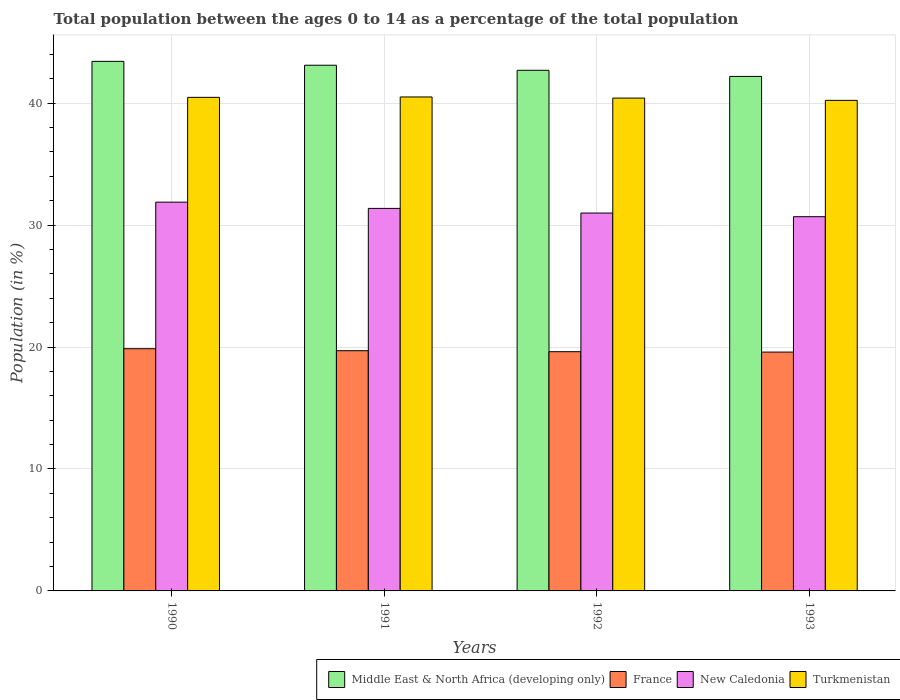How many different coloured bars are there?
Provide a short and direct response. 4. How many groups of bars are there?
Your response must be concise. 4. Are the number of bars on each tick of the X-axis equal?
Ensure brevity in your answer.  Yes. What is the label of the 2nd group of bars from the left?
Offer a very short reply. 1991. In how many cases, is the number of bars for a given year not equal to the number of legend labels?
Provide a short and direct response. 0. What is the percentage of the population ages 0 to 14 in France in 1992?
Give a very brief answer. 19.62. Across all years, what is the maximum percentage of the population ages 0 to 14 in New Caledonia?
Your answer should be compact. 31.88. Across all years, what is the minimum percentage of the population ages 0 to 14 in New Caledonia?
Provide a short and direct response. 30.68. In which year was the percentage of the population ages 0 to 14 in Middle East & North Africa (developing only) maximum?
Offer a very short reply. 1990. What is the total percentage of the population ages 0 to 14 in Middle East & North Africa (developing only) in the graph?
Your answer should be very brief. 171.4. What is the difference between the percentage of the population ages 0 to 14 in New Caledonia in 1990 and that in 1992?
Your answer should be very brief. 0.89. What is the difference between the percentage of the population ages 0 to 14 in Turkmenistan in 1993 and the percentage of the population ages 0 to 14 in Middle East & North Africa (developing only) in 1991?
Your answer should be very brief. -2.88. What is the average percentage of the population ages 0 to 14 in France per year?
Offer a terse response. 19.69. In the year 1993, what is the difference between the percentage of the population ages 0 to 14 in Turkmenistan and percentage of the population ages 0 to 14 in New Caledonia?
Offer a terse response. 9.54. In how many years, is the percentage of the population ages 0 to 14 in France greater than 6?
Your response must be concise. 4. What is the ratio of the percentage of the population ages 0 to 14 in France in 1990 to that in 1992?
Give a very brief answer. 1.01. Is the percentage of the population ages 0 to 14 in France in 1990 less than that in 1993?
Offer a terse response. No. Is the difference between the percentage of the population ages 0 to 14 in Turkmenistan in 1991 and 1993 greater than the difference between the percentage of the population ages 0 to 14 in New Caledonia in 1991 and 1993?
Ensure brevity in your answer.  No. What is the difference between the highest and the second highest percentage of the population ages 0 to 14 in Middle East & North Africa (developing only)?
Your response must be concise. 0.32. What is the difference between the highest and the lowest percentage of the population ages 0 to 14 in New Caledonia?
Offer a terse response. 1.19. Is the sum of the percentage of the population ages 0 to 14 in New Caledonia in 1990 and 1991 greater than the maximum percentage of the population ages 0 to 14 in France across all years?
Provide a short and direct response. Yes. Is it the case that in every year, the sum of the percentage of the population ages 0 to 14 in New Caledonia and percentage of the population ages 0 to 14 in France is greater than the sum of percentage of the population ages 0 to 14 in Turkmenistan and percentage of the population ages 0 to 14 in Middle East & North Africa (developing only)?
Offer a very short reply. No. What does the 4th bar from the left in 1990 represents?
Offer a very short reply. Turkmenistan. What does the 3rd bar from the right in 1992 represents?
Keep it short and to the point. France. Is it the case that in every year, the sum of the percentage of the population ages 0 to 14 in France and percentage of the population ages 0 to 14 in Middle East & North Africa (developing only) is greater than the percentage of the population ages 0 to 14 in Turkmenistan?
Make the answer very short. Yes. Are all the bars in the graph horizontal?
Provide a short and direct response. No. How many years are there in the graph?
Your answer should be very brief. 4. What is the difference between two consecutive major ticks on the Y-axis?
Make the answer very short. 10. Are the values on the major ticks of Y-axis written in scientific E-notation?
Ensure brevity in your answer.  No. Where does the legend appear in the graph?
Make the answer very short. Bottom right. What is the title of the graph?
Give a very brief answer. Total population between the ages 0 to 14 as a percentage of the total population. Does "Cayman Islands" appear as one of the legend labels in the graph?
Offer a very short reply. No. What is the label or title of the X-axis?
Your response must be concise. Years. What is the label or title of the Y-axis?
Offer a terse response. Population (in %). What is the Population (in %) of Middle East & North Africa (developing only) in 1990?
Provide a succinct answer. 43.42. What is the Population (in %) in France in 1990?
Keep it short and to the point. 19.86. What is the Population (in %) in New Caledonia in 1990?
Provide a succinct answer. 31.88. What is the Population (in %) of Turkmenistan in 1990?
Ensure brevity in your answer.  40.47. What is the Population (in %) of Middle East & North Africa (developing only) in 1991?
Offer a very short reply. 43.1. What is the Population (in %) of France in 1991?
Make the answer very short. 19.7. What is the Population (in %) in New Caledonia in 1991?
Your response must be concise. 31.36. What is the Population (in %) of Turkmenistan in 1991?
Ensure brevity in your answer.  40.5. What is the Population (in %) in Middle East & North Africa (developing only) in 1992?
Provide a succinct answer. 42.69. What is the Population (in %) of France in 1992?
Give a very brief answer. 19.62. What is the Population (in %) in New Caledonia in 1992?
Give a very brief answer. 30.98. What is the Population (in %) in Turkmenistan in 1992?
Offer a very short reply. 40.41. What is the Population (in %) of Middle East & North Africa (developing only) in 1993?
Offer a terse response. 42.19. What is the Population (in %) of France in 1993?
Give a very brief answer. 19.58. What is the Population (in %) in New Caledonia in 1993?
Your answer should be very brief. 30.68. What is the Population (in %) in Turkmenistan in 1993?
Offer a terse response. 40.22. Across all years, what is the maximum Population (in %) of Middle East & North Africa (developing only)?
Offer a terse response. 43.42. Across all years, what is the maximum Population (in %) of France?
Provide a succinct answer. 19.86. Across all years, what is the maximum Population (in %) of New Caledonia?
Ensure brevity in your answer.  31.88. Across all years, what is the maximum Population (in %) in Turkmenistan?
Your answer should be compact. 40.5. Across all years, what is the minimum Population (in %) of Middle East & North Africa (developing only)?
Provide a short and direct response. 42.19. Across all years, what is the minimum Population (in %) of France?
Offer a very short reply. 19.58. Across all years, what is the minimum Population (in %) in New Caledonia?
Provide a short and direct response. 30.68. Across all years, what is the minimum Population (in %) in Turkmenistan?
Ensure brevity in your answer.  40.22. What is the total Population (in %) of Middle East & North Africa (developing only) in the graph?
Offer a terse response. 171.4. What is the total Population (in %) in France in the graph?
Provide a short and direct response. 78.76. What is the total Population (in %) of New Caledonia in the graph?
Make the answer very short. 124.91. What is the total Population (in %) of Turkmenistan in the graph?
Make the answer very short. 161.61. What is the difference between the Population (in %) of Middle East & North Africa (developing only) in 1990 and that in 1991?
Your answer should be very brief. 0.32. What is the difference between the Population (in %) in France in 1990 and that in 1991?
Your answer should be very brief. 0.16. What is the difference between the Population (in %) of New Caledonia in 1990 and that in 1991?
Give a very brief answer. 0.51. What is the difference between the Population (in %) of Turkmenistan in 1990 and that in 1991?
Provide a succinct answer. -0.03. What is the difference between the Population (in %) in Middle East & North Africa (developing only) in 1990 and that in 1992?
Offer a very short reply. 0.73. What is the difference between the Population (in %) of France in 1990 and that in 1992?
Keep it short and to the point. 0.24. What is the difference between the Population (in %) of New Caledonia in 1990 and that in 1992?
Your response must be concise. 0.89. What is the difference between the Population (in %) of Turkmenistan in 1990 and that in 1992?
Offer a terse response. 0.06. What is the difference between the Population (in %) in Middle East & North Africa (developing only) in 1990 and that in 1993?
Your answer should be compact. 1.24. What is the difference between the Population (in %) of France in 1990 and that in 1993?
Keep it short and to the point. 0.28. What is the difference between the Population (in %) in New Caledonia in 1990 and that in 1993?
Provide a succinct answer. 1.19. What is the difference between the Population (in %) in Turkmenistan in 1990 and that in 1993?
Ensure brevity in your answer.  0.25. What is the difference between the Population (in %) in Middle East & North Africa (developing only) in 1991 and that in 1992?
Your answer should be compact. 0.42. What is the difference between the Population (in %) of France in 1991 and that in 1992?
Provide a succinct answer. 0.08. What is the difference between the Population (in %) in New Caledonia in 1991 and that in 1992?
Ensure brevity in your answer.  0.38. What is the difference between the Population (in %) of Turkmenistan in 1991 and that in 1992?
Your response must be concise. 0.09. What is the difference between the Population (in %) in Middle East & North Africa (developing only) in 1991 and that in 1993?
Provide a succinct answer. 0.92. What is the difference between the Population (in %) in France in 1991 and that in 1993?
Provide a succinct answer. 0.11. What is the difference between the Population (in %) in New Caledonia in 1991 and that in 1993?
Your answer should be compact. 0.68. What is the difference between the Population (in %) of Turkmenistan in 1991 and that in 1993?
Your answer should be compact. 0.28. What is the difference between the Population (in %) of Middle East & North Africa (developing only) in 1992 and that in 1993?
Give a very brief answer. 0.5. What is the difference between the Population (in %) in France in 1992 and that in 1993?
Make the answer very short. 0.03. What is the difference between the Population (in %) in New Caledonia in 1992 and that in 1993?
Keep it short and to the point. 0.3. What is the difference between the Population (in %) of Turkmenistan in 1992 and that in 1993?
Your answer should be very brief. 0.19. What is the difference between the Population (in %) in Middle East & North Africa (developing only) in 1990 and the Population (in %) in France in 1991?
Provide a succinct answer. 23.73. What is the difference between the Population (in %) in Middle East & North Africa (developing only) in 1990 and the Population (in %) in New Caledonia in 1991?
Offer a very short reply. 12.06. What is the difference between the Population (in %) of Middle East & North Africa (developing only) in 1990 and the Population (in %) of Turkmenistan in 1991?
Offer a terse response. 2.92. What is the difference between the Population (in %) of France in 1990 and the Population (in %) of New Caledonia in 1991?
Offer a very short reply. -11.51. What is the difference between the Population (in %) in France in 1990 and the Population (in %) in Turkmenistan in 1991?
Offer a very short reply. -20.64. What is the difference between the Population (in %) in New Caledonia in 1990 and the Population (in %) in Turkmenistan in 1991?
Make the answer very short. -8.62. What is the difference between the Population (in %) of Middle East & North Africa (developing only) in 1990 and the Population (in %) of France in 1992?
Offer a very short reply. 23.81. What is the difference between the Population (in %) of Middle East & North Africa (developing only) in 1990 and the Population (in %) of New Caledonia in 1992?
Make the answer very short. 12.44. What is the difference between the Population (in %) of Middle East & North Africa (developing only) in 1990 and the Population (in %) of Turkmenistan in 1992?
Ensure brevity in your answer.  3.01. What is the difference between the Population (in %) in France in 1990 and the Population (in %) in New Caledonia in 1992?
Make the answer very short. -11.12. What is the difference between the Population (in %) in France in 1990 and the Population (in %) in Turkmenistan in 1992?
Make the answer very short. -20.55. What is the difference between the Population (in %) in New Caledonia in 1990 and the Population (in %) in Turkmenistan in 1992?
Provide a succinct answer. -8.53. What is the difference between the Population (in %) of Middle East & North Africa (developing only) in 1990 and the Population (in %) of France in 1993?
Your response must be concise. 23.84. What is the difference between the Population (in %) of Middle East & North Africa (developing only) in 1990 and the Population (in %) of New Caledonia in 1993?
Offer a terse response. 12.74. What is the difference between the Population (in %) of Middle East & North Africa (developing only) in 1990 and the Population (in %) of Turkmenistan in 1993?
Offer a terse response. 3.2. What is the difference between the Population (in %) in France in 1990 and the Population (in %) in New Caledonia in 1993?
Make the answer very short. -10.82. What is the difference between the Population (in %) in France in 1990 and the Population (in %) in Turkmenistan in 1993?
Offer a very short reply. -20.36. What is the difference between the Population (in %) of New Caledonia in 1990 and the Population (in %) of Turkmenistan in 1993?
Offer a very short reply. -8.35. What is the difference between the Population (in %) in Middle East & North Africa (developing only) in 1991 and the Population (in %) in France in 1992?
Offer a terse response. 23.49. What is the difference between the Population (in %) in Middle East & North Africa (developing only) in 1991 and the Population (in %) in New Caledonia in 1992?
Make the answer very short. 12.12. What is the difference between the Population (in %) of Middle East & North Africa (developing only) in 1991 and the Population (in %) of Turkmenistan in 1992?
Give a very brief answer. 2.69. What is the difference between the Population (in %) in France in 1991 and the Population (in %) in New Caledonia in 1992?
Provide a succinct answer. -11.29. What is the difference between the Population (in %) in France in 1991 and the Population (in %) in Turkmenistan in 1992?
Your response must be concise. -20.71. What is the difference between the Population (in %) of New Caledonia in 1991 and the Population (in %) of Turkmenistan in 1992?
Your answer should be compact. -9.05. What is the difference between the Population (in %) in Middle East & North Africa (developing only) in 1991 and the Population (in %) in France in 1993?
Provide a short and direct response. 23.52. What is the difference between the Population (in %) of Middle East & North Africa (developing only) in 1991 and the Population (in %) of New Caledonia in 1993?
Your answer should be very brief. 12.42. What is the difference between the Population (in %) in Middle East & North Africa (developing only) in 1991 and the Population (in %) in Turkmenistan in 1993?
Your answer should be compact. 2.88. What is the difference between the Population (in %) in France in 1991 and the Population (in %) in New Caledonia in 1993?
Keep it short and to the point. -10.99. What is the difference between the Population (in %) of France in 1991 and the Population (in %) of Turkmenistan in 1993?
Your answer should be compact. -20.53. What is the difference between the Population (in %) in New Caledonia in 1991 and the Population (in %) in Turkmenistan in 1993?
Ensure brevity in your answer.  -8.86. What is the difference between the Population (in %) of Middle East & North Africa (developing only) in 1992 and the Population (in %) of France in 1993?
Offer a terse response. 23.11. What is the difference between the Population (in %) of Middle East & North Africa (developing only) in 1992 and the Population (in %) of New Caledonia in 1993?
Offer a terse response. 12. What is the difference between the Population (in %) of Middle East & North Africa (developing only) in 1992 and the Population (in %) of Turkmenistan in 1993?
Ensure brevity in your answer.  2.47. What is the difference between the Population (in %) in France in 1992 and the Population (in %) in New Caledonia in 1993?
Provide a succinct answer. -11.07. What is the difference between the Population (in %) of France in 1992 and the Population (in %) of Turkmenistan in 1993?
Offer a very short reply. -20.61. What is the difference between the Population (in %) in New Caledonia in 1992 and the Population (in %) in Turkmenistan in 1993?
Ensure brevity in your answer.  -9.24. What is the average Population (in %) of Middle East & North Africa (developing only) per year?
Your answer should be compact. 42.85. What is the average Population (in %) in France per year?
Give a very brief answer. 19.69. What is the average Population (in %) of New Caledonia per year?
Give a very brief answer. 31.23. What is the average Population (in %) of Turkmenistan per year?
Ensure brevity in your answer.  40.4. In the year 1990, what is the difference between the Population (in %) of Middle East & North Africa (developing only) and Population (in %) of France?
Ensure brevity in your answer.  23.56. In the year 1990, what is the difference between the Population (in %) of Middle East & North Africa (developing only) and Population (in %) of New Caledonia?
Your answer should be very brief. 11.54. In the year 1990, what is the difference between the Population (in %) of Middle East & North Africa (developing only) and Population (in %) of Turkmenistan?
Offer a terse response. 2.95. In the year 1990, what is the difference between the Population (in %) of France and Population (in %) of New Caledonia?
Ensure brevity in your answer.  -12.02. In the year 1990, what is the difference between the Population (in %) in France and Population (in %) in Turkmenistan?
Provide a short and direct response. -20.61. In the year 1990, what is the difference between the Population (in %) in New Caledonia and Population (in %) in Turkmenistan?
Make the answer very short. -8.59. In the year 1991, what is the difference between the Population (in %) in Middle East & North Africa (developing only) and Population (in %) in France?
Offer a very short reply. 23.41. In the year 1991, what is the difference between the Population (in %) in Middle East & North Africa (developing only) and Population (in %) in New Caledonia?
Give a very brief answer. 11.74. In the year 1991, what is the difference between the Population (in %) of Middle East & North Africa (developing only) and Population (in %) of Turkmenistan?
Your response must be concise. 2.6. In the year 1991, what is the difference between the Population (in %) of France and Population (in %) of New Caledonia?
Provide a succinct answer. -11.67. In the year 1991, what is the difference between the Population (in %) in France and Population (in %) in Turkmenistan?
Make the answer very short. -20.81. In the year 1991, what is the difference between the Population (in %) in New Caledonia and Population (in %) in Turkmenistan?
Offer a very short reply. -9.14. In the year 1992, what is the difference between the Population (in %) of Middle East & North Africa (developing only) and Population (in %) of France?
Provide a short and direct response. 23.07. In the year 1992, what is the difference between the Population (in %) in Middle East & North Africa (developing only) and Population (in %) in New Caledonia?
Make the answer very short. 11.7. In the year 1992, what is the difference between the Population (in %) in Middle East & North Africa (developing only) and Population (in %) in Turkmenistan?
Give a very brief answer. 2.28. In the year 1992, what is the difference between the Population (in %) of France and Population (in %) of New Caledonia?
Keep it short and to the point. -11.37. In the year 1992, what is the difference between the Population (in %) in France and Population (in %) in Turkmenistan?
Ensure brevity in your answer.  -20.79. In the year 1992, what is the difference between the Population (in %) of New Caledonia and Population (in %) of Turkmenistan?
Ensure brevity in your answer.  -9.43. In the year 1993, what is the difference between the Population (in %) of Middle East & North Africa (developing only) and Population (in %) of France?
Give a very brief answer. 22.6. In the year 1993, what is the difference between the Population (in %) in Middle East & North Africa (developing only) and Population (in %) in New Caledonia?
Offer a very short reply. 11.5. In the year 1993, what is the difference between the Population (in %) in Middle East & North Africa (developing only) and Population (in %) in Turkmenistan?
Offer a terse response. 1.96. In the year 1993, what is the difference between the Population (in %) of France and Population (in %) of New Caledonia?
Keep it short and to the point. -11.1. In the year 1993, what is the difference between the Population (in %) of France and Population (in %) of Turkmenistan?
Offer a very short reply. -20.64. In the year 1993, what is the difference between the Population (in %) of New Caledonia and Population (in %) of Turkmenistan?
Offer a very short reply. -9.54. What is the ratio of the Population (in %) of Middle East & North Africa (developing only) in 1990 to that in 1991?
Offer a terse response. 1.01. What is the ratio of the Population (in %) in France in 1990 to that in 1991?
Provide a short and direct response. 1.01. What is the ratio of the Population (in %) in New Caledonia in 1990 to that in 1991?
Offer a very short reply. 1.02. What is the ratio of the Population (in %) in Turkmenistan in 1990 to that in 1991?
Your answer should be very brief. 1. What is the ratio of the Population (in %) of Middle East & North Africa (developing only) in 1990 to that in 1992?
Offer a very short reply. 1.02. What is the ratio of the Population (in %) in France in 1990 to that in 1992?
Make the answer very short. 1.01. What is the ratio of the Population (in %) in New Caledonia in 1990 to that in 1992?
Keep it short and to the point. 1.03. What is the ratio of the Population (in %) of Middle East & North Africa (developing only) in 1990 to that in 1993?
Provide a short and direct response. 1.03. What is the ratio of the Population (in %) of France in 1990 to that in 1993?
Your answer should be very brief. 1.01. What is the ratio of the Population (in %) of New Caledonia in 1990 to that in 1993?
Offer a terse response. 1.04. What is the ratio of the Population (in %) in Turkmenistan in 1990 to that in 1993?
Ensure brevity in your answer.  1.01. What is the ratio of the Population (in %) of Middle East & North Africa (developing only) in 1991 to that in 1992?
Ensure brevity in your answer.  1.01. What is the ratio of the Population (in %) of France in 1991 to that in 1992?
Ensure brevity in your answer.  1. What is the ratio of the Population (in %) in New Caledonia in 1991 to that in 1992?
Provide a short and direct response. 1.01. What is the ratio of the Population (in %) in Middle East & North Africa (developing only) in 1991 to that in 1993?
Offer a terse response. 1.02. What is the ratio of the Population (in %) of France in 1991 to that in 1993?
Offer a terse response. 1.01. What is the ratio of the Population (in %) of New Caledonia in 1991 to that in 1993?
Provide a succinct answer. 1.02. What is the ratio of the Population (in %) in Turkmenistan in 1991 to that in 1993?
Offer a terse response. 1.01. What is the ratio of the Population (in %) of Middle East & North Africa (developing only) in 1992 to that in 1993?
Offer a terse response. 1.01. What is the ratio of the Population (in %) in France in 1992 to that in 1993?
Provide a short and direct response. 1. What is the ratio of the Population (in %) of New Caledonia in 1992 to that in 1993?
Offer a very short reply. 1.01. What is the difference between the highest and the second highest Population (in %) in Middle East & North Africa (developing only)?
Your response must be concise. 0.32. What is the difference between the highest and the second highest Population (in %) of France?
Offer a terse response. 0.16. What is the difference between the highest and the second highest Population (in %) in New Caledonia?
Offer a terse response. 0.51. What is the difference between the highest and the second highest Population (in %) in Turkmenistan?
Provide a short and direct response. 0.03. What is the difference between the highest and the lowest Population (in %) of Middle East & North Africa (developing only)?
Your answer should be compact. 1.24. What is the difference between the highest and the lowest Population (in %) of France?
Keep it short and to the point. 0.28. What is the difference between the highest and the lowest Population (in %) of New Caledonia?
Your response must be concise. 1.19. What is the difference between the highest and the lowest Population (in %) in Turkmenistan?
Offer a very short reply. 0.28. 